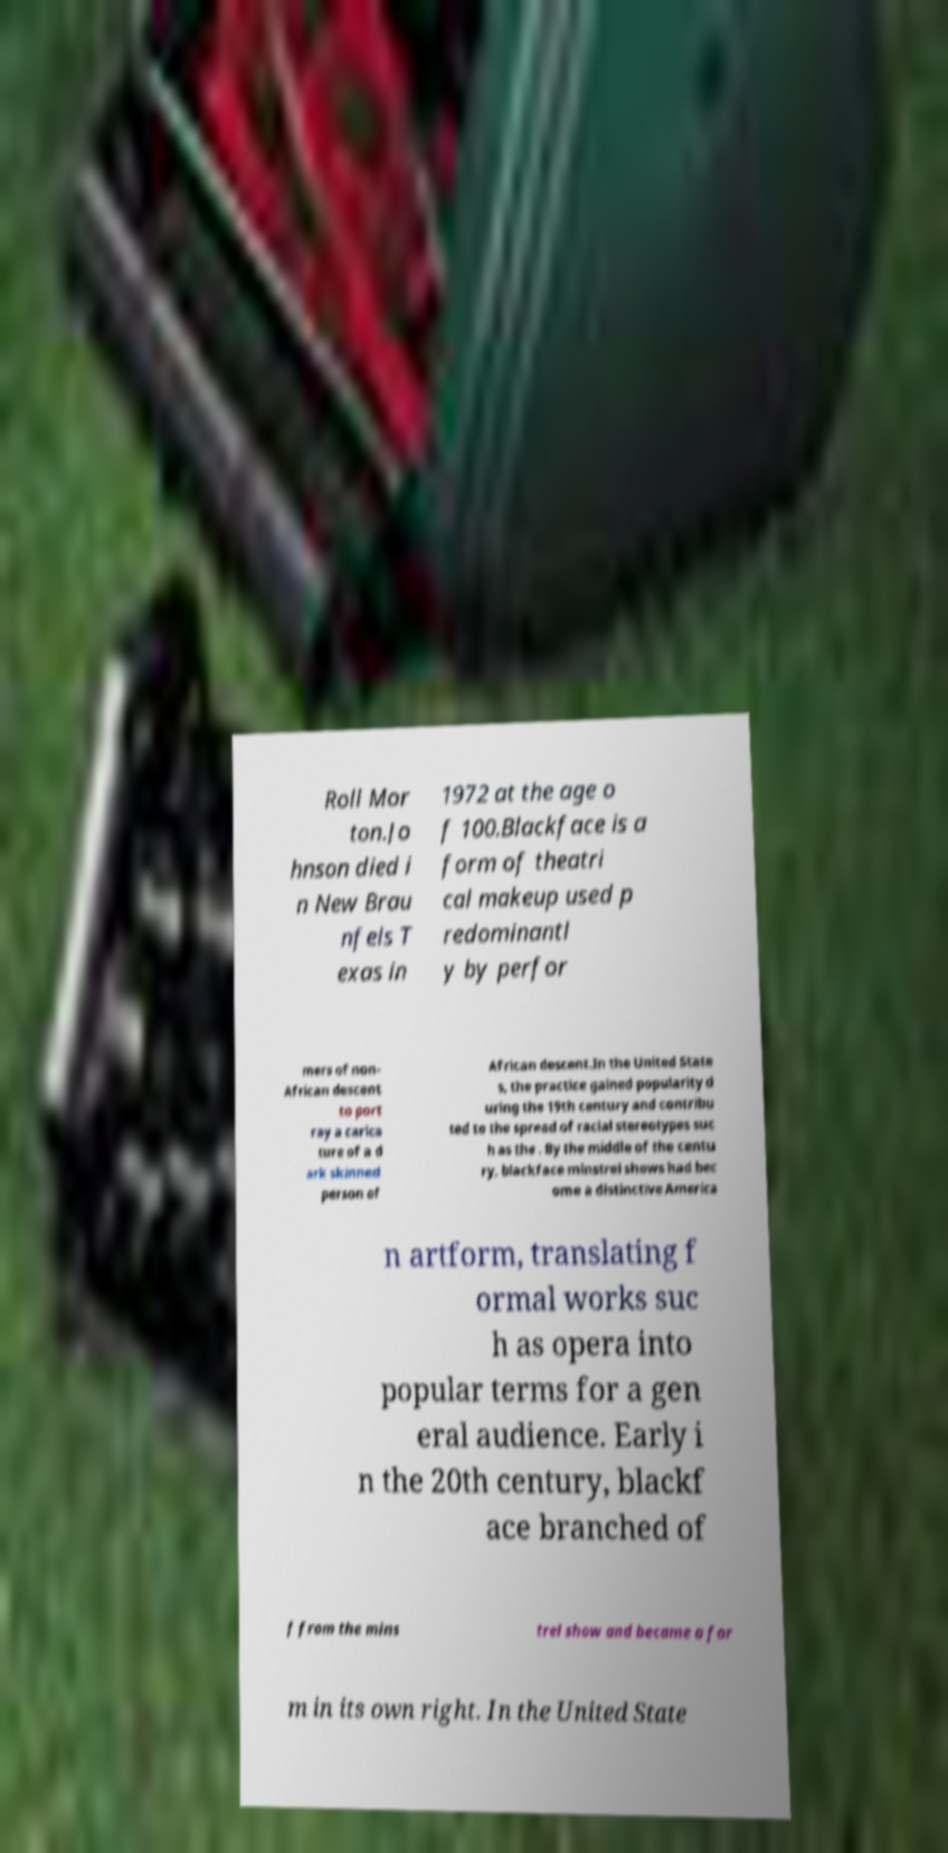I need the written content from this picture converted into text. Can you do that? Roll Mor ton.Jo hnson died i n New Brau nfels T exas in 1972 at the age o f 100.Blackface is a form of theatri cal makeup used p redominantl y by perfor mers of non- African descent to port ray a carica ture of a d ark skinned person of African descent.In the United State s, the practice gained popularity d uring the 19th century and contribu ted to the spread of racial stereotypes suc h as the . By the middle of the centu ry, blackface minstrel shows had bec ome a distinctive America n artform, translating f ormal works suc h as opera into popular terms for a gen eral audience. Early i n the 20th century, blackf ace branched of f from the mins trel show and became a for m in its own right. In the United State 